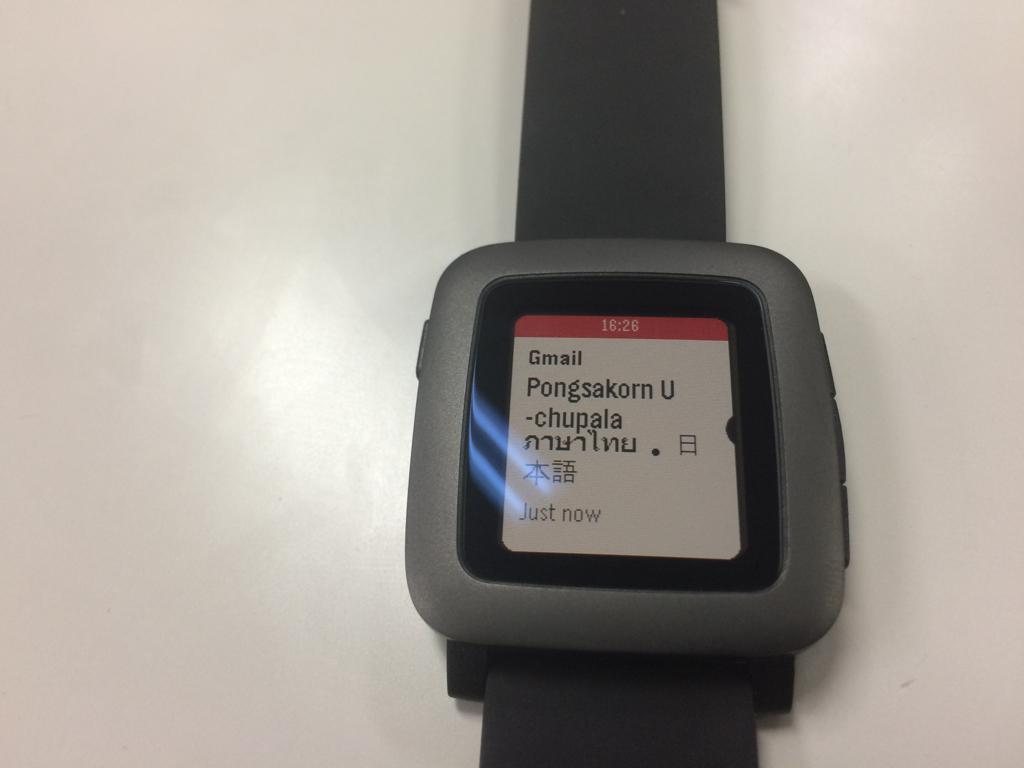<image>
Render a clear and concise summary of the photo. a clock that says Gmail on the front 